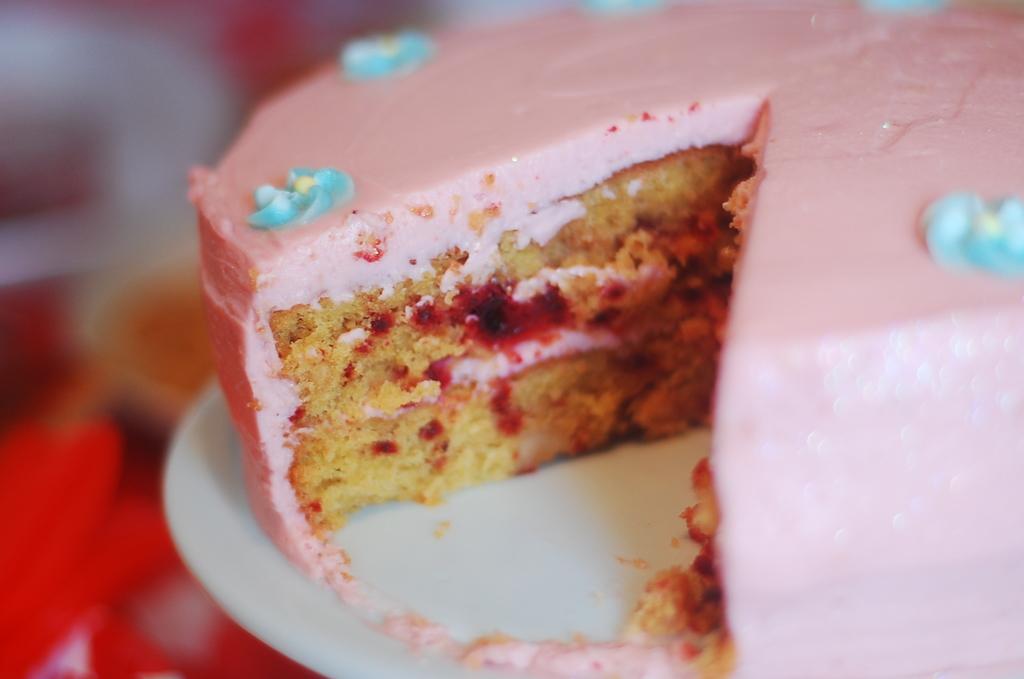Can you describe this image briefly? In this image, we can see a cake on the white surface. On the left side and top of the image, there is a blur view. 